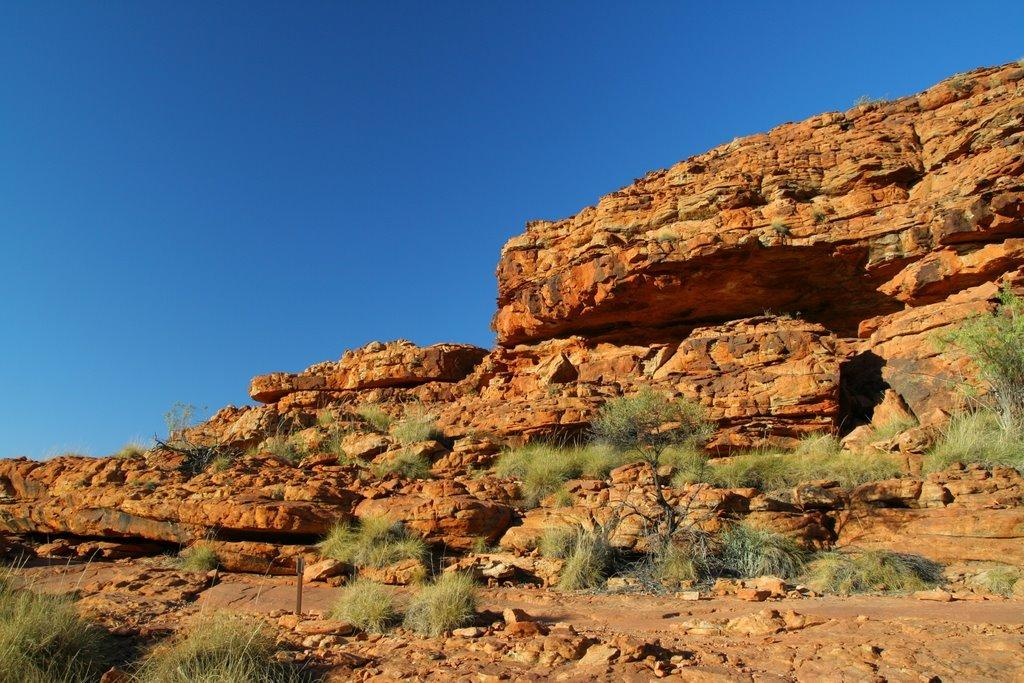What type of natural formation is present in the image? There is a mountain in the image. What other objects or features can be seen in the image? There are stones and trees visible in the image. What is visible at the top of the image? The sky is visible at the top of the image. Where is the faucet located in the image? There is no faucet present in the image. What type of drink is being served in the image? There is no drink or indication of a drink being served in the image. 